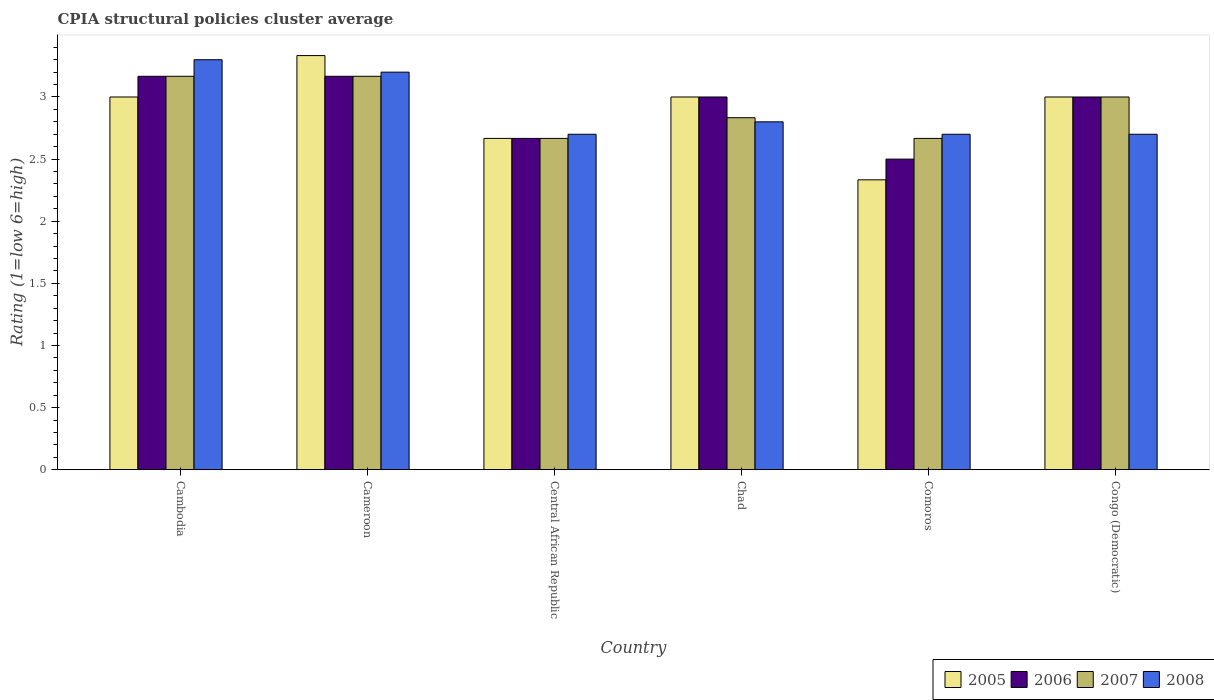Are the number of bars per tick equal to the number of legend labels?
Give a very brief answer. Yes. What is the label of the 1st group of bars from the left?
Ensure brevity in your answer.  Cambodia. In how many cases, is the number of bars for a given country not equal to the number of legend labels?
Provide a short and direct response. 0. What is the CPIA rating in 2005 in Cameroon?
Ensure brevity in your answer.  3.33. Across all countries, what is the maximum CPIA rating in 2005?
Provide a succinct answer. 3.33. Across all countries, what is the minimum CPIA rating in 2005?
Your response must be concise. 2.33. In which country was the CPIA rating in 2007 maximum?
Your answer should be compact. Cambodia. In which country was the CPIA rating in 2007 minimum?
Your answer should be compact. Central African Republic. What is the total CPIA rating in 2005 in the graph?
Provide a succinct answer. 17.33. What is the difference between the CPIA rating in 2006 in Central African Republic and the CPIA rating in 2008 in Cameroon?
Provide a short and direct response. -0.53. What is the average CPIA rating in 2007 per country?
Keep it short and to the point. 2.92. What is the difference between the CPIA rating of/in 2008 and CPIA rating of/in 2007 in Chad?
Give a very brief answer. -0.03. What is the ratio of the CPIA rating in 2006 in Central African Republic to that in Comoros?
Provide a short and direct response. 1.07. Is the CPIA rating in 2006 in Cambodia less than that in Chad?
Provide a short and direct response. No. Is the difference between the CPIA rating in 2008 in Cambodia and Cameroon greater than the difference between the CPIA rating in 2007 in Cambodia and Cameroon?
Offer a very short reply. Yes. What is the difference between the highest and the second highest CPIA rating in 2008?
Offer a terse response. 0.4. What is the difference between the highest and the lowest CPIA rating in 2008?
Offer a very short reply. 0.6. In how many countries, is the CPIA rating in 2008 greater than the average CPIA rating in 2008 taken over all countries?
Make the answer very short. 2. Is it the case that in every country, the sum of the CPIA rating in 2006 and CPIA rating in 2005 is greater than the sum of CPIA rating in 2008 and CPIA rating in 2007?
Offer a very short reply. No. What does the 2nd bar from the left in Central African Republic represents?
Your response must be concise. 2006. Is it the case that in every country, the sum of the CPIA rating in 2007 and CPIA rating in 2005 is greater than the CPIA rating in 2006?
Make the answer very short. Yes. How many bars are there?
Provide a succinct answer. 24. Are all the bars in the graph horizontal?
Make the answer very short. No. Are the values on the major ticks of Y-axis written in scientific E-notation?
Give a very brief answer. No. Does the graph contain grids?
Your response must be concise. No. How many legend labels are there?
Provide a succinct answer. 4. How are the legend labels stacked?
Keep it short and to the point. Horizontal. What is the title of the graph?
Make the answer very short. CPIA structural policies cluster average. What is the label or title of the Y-axis?
Keep it short and to the point. Rating (1=low 6=high). What is the Rating (1=low 6=high) of 2006 in Cambodia?
Offer a terse response. 3.17. What is the Rating (1=low 6=high) in 2007 in Cambodia?
Keep it short and to the point. 3.17. What is the Rating (1=low 6=high) of 2005 in Cameroon?
Your answer should be very brief. 3.33. What is the Rating (1=low 6=high) in 2006 in Cameroon?
Provide a succinct answer. 3.17. What is the Rating (1=low 6=high) in 2007 in Cameroon?
Give a very brief answer. 3.17. What is the Rating (1=low 6=high) of 2008 in Cameroon?
Keep it short and to the point. 3.2. What is the Rating (1=low 6=high) of 2005 in Central African Republic?
Give a very brief answer. 2.67. What is the Rating (1=low 6=high) of 2006 in Central African Republic?
Make the answer very short. 2.67. What is the Rating (1=low 6=high) of 2007 in Central African Republic?
Give a very brief answer. 2.67. What is the Rating (1=low 6=high) of 2008 in Central African Republic?
Give a very brief answer. 2.7. What is the Rating (1=low 6=high) of 2007 in Chad?
Provide a short and direct response. 2.83. What is the Rating (1=low 6=high) in 2008 in Chad?
Your answer should be compact. 2.8. What is the Rating (1=low 6=high) in 2005 in Comoros?
Provide a short and direct response. 2.33. What is the Rating (1=low 6=high) in 2007 in Comoros?
Your answer should be very brief. 2.67. What is the Rating (1=low 6=high) in 2005 in Congo (Democratic)?
Your response must be concise. 3. What is the Rating (1=low 6=high) of 2007 in Congo (Democratic)?
Your response must be concise. 3. What is the Rating (1=low 6=high) in 2008 in Congo (Democratic)?
Ensure brevity in your answer.  2.7. Across all countries, what is the maximum Rating (1=low 6=high) in 2005?
Provide a short and direct response. 3.33. Across all countries, what is the maximum Rating (1=low 6=high) of 2006?
Ensure brevity in your answer.  3.17. Across all countries, what is the maximum Rating (1=low 6=high) in 2007?
Keep it short and to the point. 3.17. Across all countries, what is the minimum Rating (1=low 6=high) of 2005?
Keep it short and to the point. 2.33. Across all countries, what is the minimum Rating (1=low 6=high) in 2007?
Ensure brevity in your answer.  2.67. What is the total Rating (1=low 6=high) in 2005 in the graph?
Offer a terse response. 17.33. What is the total Rating (1=low 6=high) of 2007 in the graph?
Keep it short and to the point. 17.5. What is the total Rating (1=low 6=high) in 2008 in the graph?
Ensure brevity in your answer.  17.4. What is the difference between the Rating (1=low 6=high) in 2005 in Cambodia and that in Cameroon?
Your answer should be very brief. -0.33. What is the difference between the Rating (1=low 6=high) of 2006 in Cambodia and that in Central African Republic?
Provide a short and direct response. 0.5. What is the difference between the Rating (1=low 6=high) in 2007 in Cambodia and that in Central African Republic?
Your answer should be very brief. 0.5. What is the difference between the Rating (1=low 6=high) in 2005 in Cambodia and that in Chad?
Your answer should be compact. 0. What is the difference between the Rating (1=low 6=high) of 2006 in Cambodia and that in Chad?
Make the answer very short. 0.17. What is the difference between the Rating (1=low 6=high) of 2008 in Cambodia and that in Chad?
Offer a very short reply. 0.5. What is the difference between the Rating (1=low 6=high) of 2005 in Cambodia and that in Comoros?
Offer a very short reply. 0.67. What is the difference between the Rating (1=low 6=high) of 2006 in Cambodia and that in Comoros?
Offer a terse response. 0.67. What is the difference between the Rating (1=low 6=high) of 2007 in Cambodia and that in Comoros?
Keep it short and to the point. 0.5. What is the difference between the Rating (1=low 6=high) in 2008 in Cambodia and that in Comoros?
Provide a short and direct response. 0.6. What is the difference between the Rating (1=low 6=high) in 2005 in Cambodia and that in Congo (Democratic)?
Provide a succinct answer. 0. What is the difference between the Rating (1=low 6=high) in 2006 in Cambodia and that in Congo (Democratic)?
Ensure brevity in your answer.  0.17. What is the difference between the Rating (1=low 6=high) of 2007 in Cambodia and that in Congo (Democratic)?
Make the answer very short. 0.17. What is the difference between the Rating (1=low 6=high) in 2005 in Cameroon and that in Central African Republic?
Ensure brevity in your answer.  0.67. What is the difference between the Rating (1=low 6=high) of 2007 in Cameroon and that in Central African Republic?
Your answer should be very brief. 0.5. What is the difference between the Rating (1=low 6=high) of 2008 in Cameroon and that in Central African Republic?
Make the answer very short. 0.5. What is the difference between the Rating (1=low 6=high) in 2007 in Cameroon and that in Chad?
Offer a terse response. 0.33. What is the difference between the Rating (1=low 6=high) in 2005 in Cameroon and that in Comoros?
Make the answer very short. 1. What is the difference between the Rating (1=low 6=high) in 2006 in Cameroon and that in Comoros?
Offer a terse response. 0.67. What is the difference between the Rating (1=low 6=high) of 2008 in Cameroon and that in Comoros?
Provide a succinct answer. 0.5. What is the difference between the Rating (1=low 6=high) in 2007 in Cameroon and that in Congo (Democratic)?
Provide a short and direct response. 0.17. What is the difference between the Rating (1=low 6=high) of 2006 in Central African Republic and that in Chad?
Your answer should be very brief. -0.33. What is the difference between the Rating (1=low 6=high) in 2007 in Central African Republic and that in Chad?
Give a very brief answer. -0.17. What is the difference between the Rating (1=low 6=high) in 2008 in Central African Republic and that in Chad?
Your answer should be compact. -0.1. What is the difference between the Rating (1=low 6=high) of 2005 in Central African Republic and that in Comoros?
Your answer should be compact. 0.33. What is the difference between the Rating (1=low 6=high) in 2007 in Central African Republic and that in Comoros?
Provide a short and direct response. 0. What is the difference between the Rating (1=low 6=high) in 2006 in Central African Republic and that in Congo (Democratic)?
Provide a short and direct response. -0.33. What is the difference between the Rating (1=low 6=high) of 2007 in Central African Republic and that in Congo (Democratic)?
Provide a succinct answer. -0.33. What is the difference between the Rating (1=low 6=high) of 2005 in Chad and that in Comoros?
Offer a very short reply. 0.67. What is the difference between the Rating (1=low 6=high) of 2007 in Chad and that in Comoros?
Provide a short and direct response. 0.17. What is the difference between the Rating (1=low 6=high) of 2008 in Chad and that in Comoros?
Give a very brief answer. 0.1. What is the difference between the Rating (1=low 6=high) of 2006 in Chad and that in Congo (Democratic)?
Your response must be concise. 0. What is the difference between the Rating (1=low 6=high) in 2005 in Comoros and that in Congo (Democratic)?
Ensure brevity in your answer.  -0.67. What is the difference between the Rating (1=low 6=high) of 2006 in Cambodia and the Rating (1=low 6=high) of 2007 in Cameroon?
Offer a very short reply. 0. What is the difference between the Rating (1=low 6=high) in 2006 in Cambodia and the Rating (1=low 6=high) in 2008 in Cameroon?
Make the answer very short. -0.03. What is the difference between the Rating (1=low 6=high) of 2007 in Cambodia and the Rating (1=low 6=high) of 2008 in Cameroon?
Offer a terse response. -0.03. What is the difference between the Rating (1=low 6=high) of 2005 in Cambodia and the Rating (1=low 6=high) of 2006 in Central African Republic?
Offer a terse response. 0.33. What is the difference between the Rating (1=low 6=high) of 2006 in Cambodia and the Rating (1=low 6=high) of 2008 in Central African Republic?
Offer a very short reply. 0.47. What is the difference between the Rating (1=low 6=high) of 2007 in Cambodia and the Rating (1=low 6=high) of 2008 in Central African Republic?
Offer a very short reply. 0.47. What is the difference between the Rating (1=low 6=high) in 2005 in Cambodia and the Rating (1=low 6=high) in 2008 in Chad?
Make the answer very short. 0.2. What is the difference between the Rating (1=low 6=high) in 2006 in Cambodia and the Rating (1=low 6=high) in 2008 in Chad?
Offer a terse response. 0.37. What is the difference between the Rating (1=low 6=high) of 2007 in Cambodia and the Rating (1=low 6=high) of 2008 in Chad?
Provide a short and direct response. 0.37. What is the difference between the Rating (1=low 6=high) in 2005 in Cambodia and the Rating (1=low 6=high) in 2006 in Comoros?
Keep it short and to the point. 0.5. What is the difference between the Rating (1=low 6=high) of 2005 in Cambodia and the Rating (1=low 6=high) of 2007 in Comoros?
Ensure brevity in your answer.  0.33. What is the difference between the Rating (1=low 6=high) of 2005 in Cambodia and the Rating (1=low 6=high) of 2008 in Comoros?
Your response must be concise. 0.3. What is the difference between the Rating (1=low 6=high) in 2006 in Cambodia and the Rating (1=low 6=high) in 2008 in Comoros?
Your answer should be compact. 0.47. What is the difference between the Rating (1=low 6=high) in 2007 in Cambodia and the Rating (1=low 6=high) in 2008 in Comoros?
Provide a short and direct response. 0.47. What is the difference between the Rating (1=low 6=high) in 2005 in Cambodia and the Rating (1=low 6=high) in 2008 in Congo (Democratic)?
Provide a succinct answer. 0.3. What is the difference between the Rating (1=low 6=high) in 2006 in Cambodia and the Rating (1=low 6=high) in 2008 in Congo (Democratic)?
Provide a succinct answer. 0.47. What is the difference between the Rating (1=low 6=high) of 2007 in Cambodia and the Rating (1=low 6=high) of 2008 in Congo (Democratic)?
Offer a terse response. 0.47. What is the difference between the Rating (1=low 6=high) in 2005 in Cameroon and the Rating (1=low 6=high) in 2006 in Central African Republic?
Offer a very short reply. 0.67. What is the difference between the Rating (1=low 6=high) in 2005 in Cameroon and the Rating (1=low 6=high) in 2007 in Central African Republic?
Keep it short and to the point. 0.67. What is the difference between the Rating (1=low 6=high) in 2005 in Cameroon and the Rating (1=low 6=high) in 2008 in Central African Republic?
Ensure brevity in your answer.  0.63. What is the difference between the Rating (1=low 6=high) of 2006 in Cameroon and the Rating (1=low 6=high) of 2007 in Central African Republic?
Offer a terse response. 0.5. What is the difference between the Rating (1=low 6=high) in 2006 in Cameroon and the Rating (1=low 6=high) in 2008 in Central African Republic?
Ensure brevity in your answer.  0.47. What is the difference between the Rating (1=low 6=high) of 2007 in Cameroon and the Rating (1=low 6=high) of 2008 in Central African Republic?
Ensure brevity in your answer.  0.47. What is the difference between the Rating (1=low 6=high) of 2005 in Cameroon and the Rating (1=low 6=high) of 2006 in Chad?
Offer a terse response. 0.33. What is the difference between the Rating (1=low 6=high) of 2005 in Cameroon and the Rating (1=low 6=high) of 2008 in Chad?
Give a very brief answer. 0.53. What is the difference between the Rating (1=low 6=high) of 2006 in Cameroon and the Rating (1=low 6=high) of 2007 in Chad?
Your answer should be compact. 0.33. What is the difference between the Rating (1=low 6=high) of 2006 in Cameroon and the Rating (1=low 6=high) of 2008 in Chad?
Your response must be concise. 0.37. What is the difference between the Rating (1=low 6=high) of 2007 in Cameroon and the Rating (1=low 6=high) of 2008 in Chad?
Keep it short and to the point. 0.37. What is the difference between the Rating (1=low 6=high) of 2005 in Cameroon and the Rating (1=low 6=high) of 2006 in Comoros?
Your answer should be compact. 0.83. What is the difference between the Rating (1=low 6=high) in 2005 in Cameroon and the Rating (1=low 6=high) in 2007 in Comoros?
Your response must be concise. 0.67. What is the difference between the Rating (1=low 6=high) of 2005 in Cameroon and the Rating (1=low 6=high) of 2008 in Comoros?
Make the answer very short. 0.63. What is the difference between the Rating (1=low 6=high) of 2006 in Cameroon and the Rating (1=low 6=high) of 2008 in Comoros?
Your response must be concise. 0.47. What is the difference between the Rating (1=low 6=high) of 2007 in Cameroon and the Rating (1=low 6=high) of 2008 in Comoros?
Provide a succinct answer. 0.47. What is the difference between the Rating (1=low 6=high) of 2005 in Cameroon and the Rating (1=low 6=high) of 2008 in Congo (Democratic)?
Offer a terse response. 0.63. What is the difference between the Rating (1=low 6=high) of 2006 in Cameroon and the Rating (1=low 6=high) of 2007 in Congo (Democratic)?
Offer a terse response. 0.17. What is the difference between the Rating (1=low 6=high) of 2006 in Cameroon and the Rating (1=low 6=high) of 2008 in Congo (Democratic)?
Your response must be concise. 0.47. What is the difference between the Rating (1=low 6=high) of 2007 in Cameroon and the Rating (1=low 6=high) of 2008 in Congo (Democratic)?
Offer a terse response. 0.47. What is the difference between the Rating (1=low 6=high) in 2005 in Central African Republic and the Rating (1=low 6=high) in 2006 in Chad?
Provide a short and direct response. -0.33. What is the difference between the Rating (1=low 6=high) of 2005 in Central African Republic and the Rating (1=low 6=high) of 2007 in Chad?
Your answer should be compact. -0.17. What is the difference between the Rating (1=low 6=high) of 2005 in Central African Republic and the Rating (1=low 6=high) of 2008 in Chad?
Make the answer very short. -0.13. What is the difference between the Rating (1=low 6=high) in 2006 in Central African Republic and the Rating (1=low 6=high) in 2008 in Chad?
Offer a terse response. -0.13. What is the difference between the Rating (1=low 6=high) in 2007 in Central African Republic and the Rating (1=low 6=high) in 2008 in Chad?
Ensure brevity in your answer.  -0.13. What is the difference between the Rating (1=low 6=high) of 2005 in Central African Republic and the Rating (1=low 6=high) of 2006 in Comoros?
Your answer should be compact. 0.17. What is the difference between the Rating (1=low 6=high) of 2005 in Central African Republic and the Rating (1=low 6=high) of 2007 in Comoros?
Provide a short and direct response. 0. What is the difference between the Rating (1=low 6=high) in 2005 in Central African Republic and the Rating (1=low 6=high) in 2008 in Comoros?
Provide a short and direct response. -0.03. What is the difference between the Rating (1=low 6=high) in 2006 in Central African Republic and the Rating (1=low 6=high) in 2008 in Comoros?
Your answer should be compact. -0.03. What is the difference between the Rating (1=low 6=high) in 2007 in Central African Republic and the Rating (1=low 6=high) in 2008 in Comoros?
Offer a terse response. -0.03. What is the difference between the Rating (1=low 6=high) in 2005 in Central African Republic and the Rating (1=low 6=high) in 2006 in Congo (Democratic)?
Your response must be concise. -0.33. What is the difference between the Rating (1=low 6=high) in 2005 in Central African Republic and the Rating (1=low 6=high) in 2008 in Congo (Democratic)?
Offer a very short reply. -0.03. What is the difference between the Rating (1=low 6=high) of 2006 in Central African Republic and the Rating (1=low 6=high) of 2007 in Congo (Democratic)?
Make the answer very short. -0.33. What is the difference between the Rating (1=low 6=high) of 2006 in Central African Republic and the Rating (1=low 6=high) of 2008 in Congo (Democratic)?
Offer a very short reply. -0.03. What is the difference between the Rating (1=low 6=high) of 2007 in Central African Republic and the Rating (1=low 6=high) of 2008 in Congo (Democratic)?
Your response must be concise. -0.03. What is the difference between the Rating (1=low 6=high) of 2006 in Chad and the Rating (1=low 6=high) of 2007 in Comoros?
Your answer should be compact. 0.33. What is the difference between the Rating (1=low 6=high) in 2006 in Chad and the Rating (1=low 6=high) in 2008 in Comoros?
Make the answer very short. 0.3. What is the difference between the Rating (1=low 6=high) in 2007 in Chad and the Rating (1=low 6=high) in 2008 in Comoros?
Provide a short and direct response. 0.13. What is the difference between the Rating (1=low 6=high) of 2005 in Chad and the Rating (1=low 6=high) of 2006 in Congo (Democratic)?
Your answer should be compact. 0. What is the difference between the Rating (1=low 6=high) in 2005 in Chad and the Rating (1=low 6=high) in 2008 in Congo (Democratic)?
Keep it short and to the point. 0.3. What is the difference between the Rating (1=low 6=high) of 2006 in Chad and the Rating (1=low 6=high) of 2007 in Congo (Democratic)?
Offer a terse response. 0. What is the difference between the Rating (1=low 6=high) of 2007 in Chad and the Rating (1=low 6=high) of 2008 in Congo (Democratic)?
Provide a short and direct response. 0.13. What is the difference between the Rating (1=low 6=high) of 2005 in Comoros and the Rating (1=low 6=high) of 2006 in Congo (Democratic)?
Provide a succinct answer. -0.67. What is the difference between the Rating (1=low 6=high) in 2005 in Comoros and the Rating (1=low 6=high) in 2008 in Congo (Democratic)?
Offer a terse response. -0.37. What is the difference between the Rating (1=low 6=high) in 2007 in Comoros and the Rating (1=low 6=high) in 2008 in Congo (Democratic)?
Give a very brief answer. -0.03. What is the average Rating (1=low 6=high) in 2005 per country?
Offer a very short reply. 2.89. What is the average Rating (1=low 6=high) in 2006 per country?
Give a very brief answer. 2.92. What is the average Rating (1=low 6=high) of 2007 per country?
Your response must be concise. 2.92. What is the average Rating (1=low 6=high) of 2008 per country?
Keep it short and to the point. 2.9. What is the difference between the Rating (1=low 6=high) in 2005 and Rating (1=low 6=high) in 2006 in Cambodia?
Offer a terse response. -0.17. What is the difference between the Rating (1=low 6=high) in 2005 and Rating (1=low 6=high) in 2007 in Cambodia?
Make the answer very short. -0.17. What is the difference between the Rating (1=low 6=high) in 2006 and Rating (1=low 6=high) in 2008 in Cambodia?
Offer a very short reply. -0.13. What is the difference between the Rating (1=low 6=high) in 2007 and Rating (1=low 6=high) in 2008 in Cambodia?
Your answer should be compact. -0.13. What is the difference between the Rating (1=low 6=high) of 2005 and Rating (1=low 6=high) of 2008 in Cameroon?
Provide a succinct answer. 0.13. What is the difference between the Rating (1=low 6=high) in 2006 and Rating (1=low 6=high) in 2007 in Cameroon?
Your answer should be very brief. 0. What is the difference between the Rating (1=low 6=high) of 2006 and Rating (1=low 6=high) of 2008 in Cameroon?
Offer a terse response. -0.03. What is the difference between the Rating (1=low 6=high) in 2007 and Rating (1=low 6=high) in 2008 in Cameroon?
Your answer should be very brief. -0.03. What is the difference between the Rating (1=low 6=high) in 2005 and Rating (1=low 6=high) in 2007 in Central African Republic?
Keep it short and to the point. 0. What is the difference between the Rating (1=low 6=high) of 2005 and Rating (1=low 6=high) of 2008 in Central African Republic?
Make the answer very short. -0.03. What is the difference between the Rating (1=low 6=high) in 2006 and Rating (1=low 6=high) in 2007 in Central African Republic?
Your response must be concise. 0. What is the difference between the Rating (1=low 6=high) in 2006 and Rating (1=low 6=high) in 2008 in Central African Republic?
Your answer should be compact. -0.03. What is the difference between the Rating (1=low 6=high) in 2007 and Rating (1=low 6=high) in 2008 in Central African Republic?
Offer a very short reply. -0.03. What is the difference between the Rating (1=low 6=high) in 2005 and Rating (1=low 6=high) in 2006 in Chad?
Your answer should be compact. 0. What is the difference between the Rating (1=low 6=high) in 2005 and Rating (1=low 6=high) in 2007 in Chad?
Offer a very short reply. 0.17. What is the difference between the Rating (1=low 6=high) of 2006 and Rating (1=low 6=high) of 2008 in Chad?
Make the answer very short. 0.2. What is the difference between the Rating (1=low 6=high) of 2005 and Rating (1=low 6=high) of 2006 in Comoros?
Your answer should be compact. -0.17. What is the difference between the Rating (1=low 6=high) in 2005 and Rating (1=low 6=high) in 2007 in Comoros?
Give a very brief answer. -0.33. What is the difference between the Rating (1=low 6=high) in 2005 and Rating (1=low 6=high) in 2008 in Comoros?
Ensure brevity in your answer.  -0.37. What is the difference between the Rating (1=low 6=high) of 2006 and Rating (1=low 6=high) of 2007 in Comoros?
Ensure brevity in your answer.  -0.17. What is the difference between the Rating (1=low 6=high) in 2006 and Rating (1=low 6=high) in 2008 in Comoros?
Your answer should be compact. -0.2. What is the difference between the Rating (1=low 6=high) in 2007 and Rating (1=low 6=high) in 2008 in Comoros?
Offer a very short reply. -0.03. What is the difference between the Rating (1=low 6=high) in 2005 and Rating (1=low 6=high) in 2006 in Congo (Democratic)?
Provide a succinct answer. 0. What is the ratio of the Rating (1=low 6=high) of 2007 in Cambodia to that in Cameroon?
Offer a terse response. 1. What is the ratio of the Rating (1=low 6=high) of 2008 in Cambodia to that in Cameroon?
Give a very brief answer. 1.03. What is the ratio of the Rating (1=low 6=high) in 2005 in Cambodia to that in Central African Republic?
Your response must be concise. 1.12. What is the ratio of the Rating (1=low 6=high) of 2006 in Cambodia to that in Central African Republic?
Ensure brevity in your answer.  1.19. What is the ratio of the Rating (1=low 6=high) in 2007 in Cambodia to that in Central African Republic?
Your response must be concise. 1.19. What is the ratio of the Rating (1=low 6=high) of 2008 in Cambodia to that in Central African Republic?
Give a very brief answer. 1.22. What is the ratio of the Rating (1=low 6=high) of 2006 in Cambodia to that in Chad?
Give a very brief answer. 1.06. What is the ratio of the Rating (1=low 6=high) of 2007 in Cambodia to that in Chad?
Make the answer very short. 1.12. What is the ratio of the Rating (1=low 6=high) of 2008 in Cambodia to that in Chad?
Offer a terse response. 1.18. What is the ratio of the Rating (1=low 6=high) in 2006 in Cambodia to that in Comoros?
Offer a terse response. 1.27. What is the ratio of the Rating (1=low 6=high) of 2007 in Cambodia to that in Comoros?
Provide a short and direct response. 1.19. What is the ratio of the Rating (1=low 6=high) of 2008 in Cambodia to that in Comoros?
Provide a short and direct response. 1.22. What is the ratio of the Rating (1=low 6=high) in 2005 in Cambodia to that in Congo (Democratic)?
Offer a very short reply. 1. What is the ratio of the Rating (1=low 6=high) of 2006 in Cambodia to that in Congo (Democratic)?
Provide a short and direct response. 1.06. What is the ratio of the Rating (1=low 6=high) in 2007 in Cambodia to that in Congo (Democratic)?
Give a very brief answer. 1.06. What is the ratio of the Rating (1=low 6=high) of 2008 in Cambodia to that in Congo (Democratic)?
Provide a succinct answer. 1.22. What is the ratio of the Rating (1=low 6=high) in 2005 in Cameroon to that in Central African Republic?
Your answer should be very brief. 1.25. What is the ratio of the Rating (1=low 6=high) of 2006 in Cameroon to that in Central African Republic?
Your answer should be very brief. 1.19. What is the ratio of the Rating (1=low 6=high) of 2007 in Cameroon to that in Central African Republic?
Provide a short and direct response. 1.19. What is the ratio of the Rating (1=low 6=high) of 2008 in Cameroon to that in Central African Republic?
Offer a very short reply. 1.19. What is the ratio of the Rating (1=low 6=high) of 2006 in Cameroon to that in Chad?
Give a very brief answer. 1.06. What is the ratio of the Rating (1=low 6=high) of 2007 in Cameroon to that in Chad?
Provide a short and direct response. 1.12. What is the ratio of the Rating (1=low 6=high) in 2008 in Cameroon to that in Chad?
Give a very brief answer. 1.14. What is the ratio of the Rating (1=low 6=high) of 2005 in Cameroon to that in Comoros?
Offer a terse response. 1.43. What is the ratio of the Rating (1=low 6=high) in 2006 in Cameroon to that in Comoros?
Ensure brevity in your answer.  1.27. What is the ratio of the Rating (1=low 6=high) in 2007 in Cameroon to that in Comoros?
Make the answer very short. 1.19. What is the ratio of the Rating (1=low 6=high) of 2008 in Cameroon to that in Comoros?
Your answer should be compact. 1.19. What is the ratio of the Rating (1=low 6=high) in 2005 in Cameroon to that in Congo (Democratic)?
Give a very brief answer. 1.11. What is the ratio of the Rating (1=low 6=high) of 2006 in Cameroon to that in Congo (Democratic)?
Make the answer very short. 1.06. What is the ratio of the Rating (1=low 6=high) of 2007 in Cameroon to that in Congo (Democratic)?
Your response must be concise. 1.06. What is the ratio of the Rating (1=low 6=high) in 2008 in Cameroon to that in Congo (Democratic)?
Offer a very short reply. 1.19. What is the ratio of the Rating (1=low 6=high) of 2005 in Central African Republic to that in Chad?
Your answer should be very brief. 0.89. What is the ratio of the Rating (1=low 6=high) of 2006 in Central African Republic to that in Chad?
Offer a terse response. 0.89. What is the ratio of the Rating (1=low 6=high) in 2006 in Central African Republic to that in Comoros?
Offer a terse response. 1.07. What is the ratio of the Rating (1=low 6=high) in 2007 in Central African Republic to that in Comoros?
Your answer should be compact. 1. What is the ratio of the Rating (1=low 6=high) of 2008 in Central African Republic to that in Comoros?
Your response must be concise. 1. What is the ratio of the Rating (1=low 6=high) of 2005 in Central African Republic to that in Congo (Democratic)?
Ensure brevity in your answer.  0.89. What is the ratio of the Rating (1=low 6=high) of 2006 in Central African Republic to that in Congo (Democratic)?
Offer a terse response. 0.89. What is the ratio of the Rating (1=low 6=high) of 2008 in Central African Republic to that in Congo (Democratic)?
Your answer should be compact. 1. What is the ratio of the Rating (1=low 6=high) of 2005 in Chad to that in Comoros?
Your answer should be very brief. 1.29. What is the ratio of the Rating (1=low 6=high) of 2006 in Chad to that in Comoros?
Offer a terse response. 1.2. What is the ratio of the Rating (1=low 6=high) of 2007 in Chad to that in Comoros?
Your answer should be compact. 1.06. What is the ratio of the Rating (1=low 6=high) of 2008 in Chad to that in Comoros?
Give a very brief answer. 1.04. What is the ratio of the Rating (1=low 6=high) in 2007 in Chad to that in Congo (Democratic)?
Ensure brevity in your answer.  0.94. What is the ratio of the Rating (1=low 6=high) in 2008 in Chad to that in Congo (Democratic)?
Keep it short and to the point. 1.04. What is the ratio of the Rating (1=low 6=high) in 2007 in Comoros to that in Congo (Democratic)?
Your response must be concise. 0.89. What is the difference between the highest and the second highest Rating (1=low 6=high) of 2006?
Provide a short and direct response. 0. What is the difference between the highest and the second highest Rating (1=low 6=high) in 2007?
Your answer should be compact. 0. What is the difference between the highest and the second highest Rating (1=low 6=high) of 2008?
Provide a succinct answer. 0.1. What is the difference between the highest and the lowest Rating (1=low 6=high) of 2006?
Your response must be concise. 0.67. What is the difference between the highest and the lowest Rating (1=low 6=high) in 2007?
Provide a succinct answer. 0.5. What is the difference between the highest and the lowest Rating (1=low 6=high) in 2008?
Your response must be concise. 0.6. 